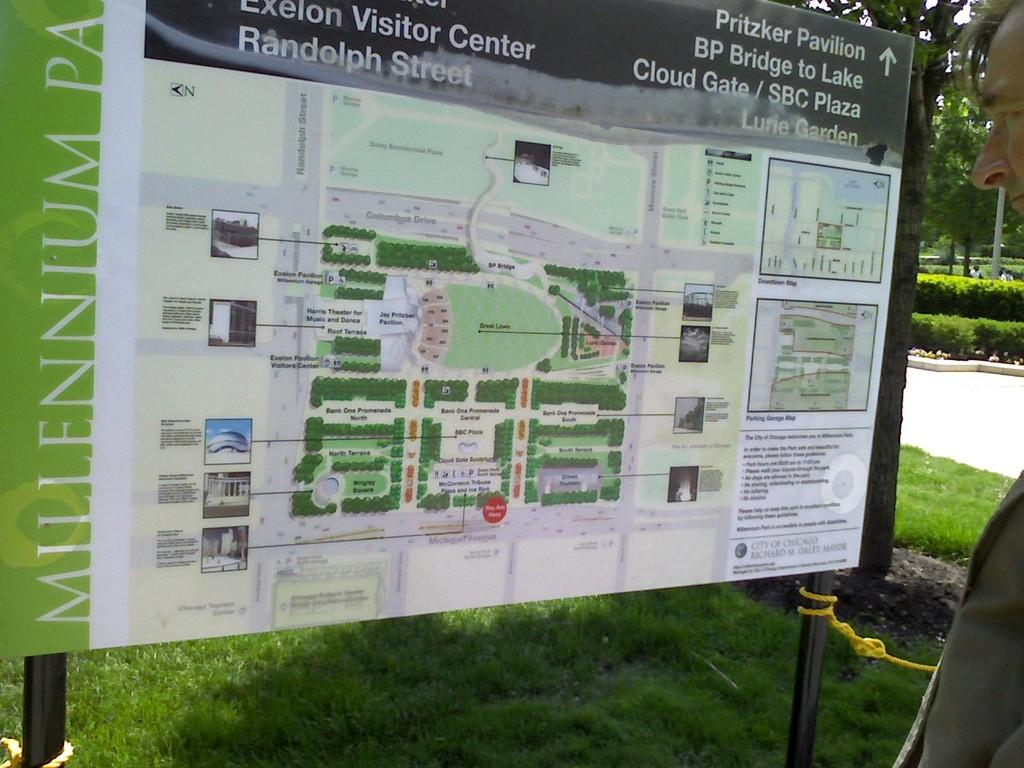What is the main object in the image? There is a board in the image. What is depicted on the board? There is a map on the board. What can be seen written on the board? Something is written on the board. What type of natural environment is visible in the image? There is grass, plants, and trees visible in the image. Can you describe the person in the image? There is a man in the image. What type of juice is the man drinking in the image? There is no juice present in the image; the man is not depicted with any drink. Is there a crook in the image? There is no crook present in the image. 